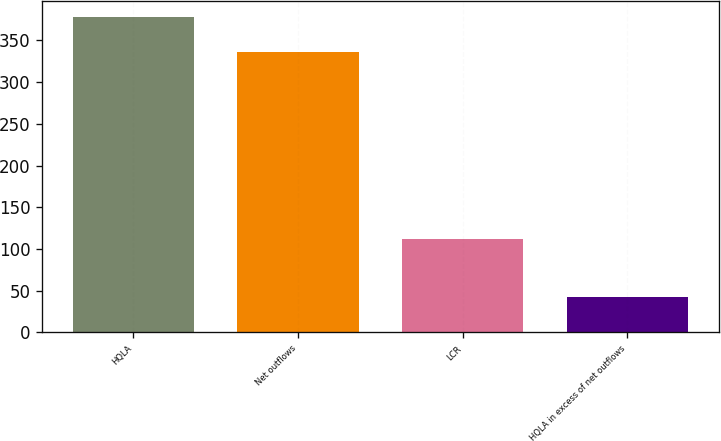Convert chart to OTSL. <chart><loc_0><loc_0><loc_500><loc_500><bar_chart><fcel>HQLA<fcel>Net outflows<fcel>LCR<fcel>HQLA in excess of net outflows<nl><fcel>378.5<fcel>336.5<fcel>112<fcel>42<nl></chart> 